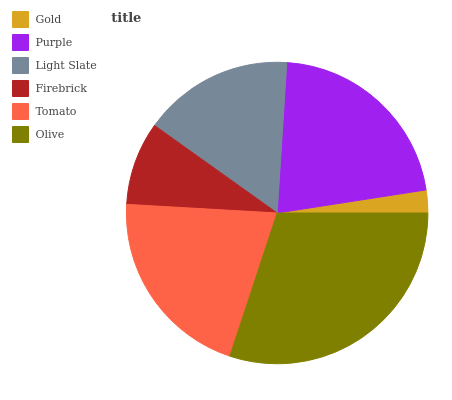Is Gold the minimum?
Answer yes or no. Yes. Is Olive the maximum?
Answer yes or no. Yes. Is Purple the minimum?
Answer yes or no. No. Is Purple the maximum?
Answer yes or no. No. Is Purple greater than Gold?
Answer yes or no. Yes. Is Gold less than Purple?
Answer yes or no. Yes. Is Gold greater than Purple?
Answer yes or no. No. Is Purple less than Gold?
Answer yes or no. No. Is Tomato the high median?
Answer yes or no. Yes. Is Light Slate the low median?
Answer yes or no. Yes. Is Purple the high median?
Answer yes or no. No. Is Gold the low median?
Answer yes or no. No. 